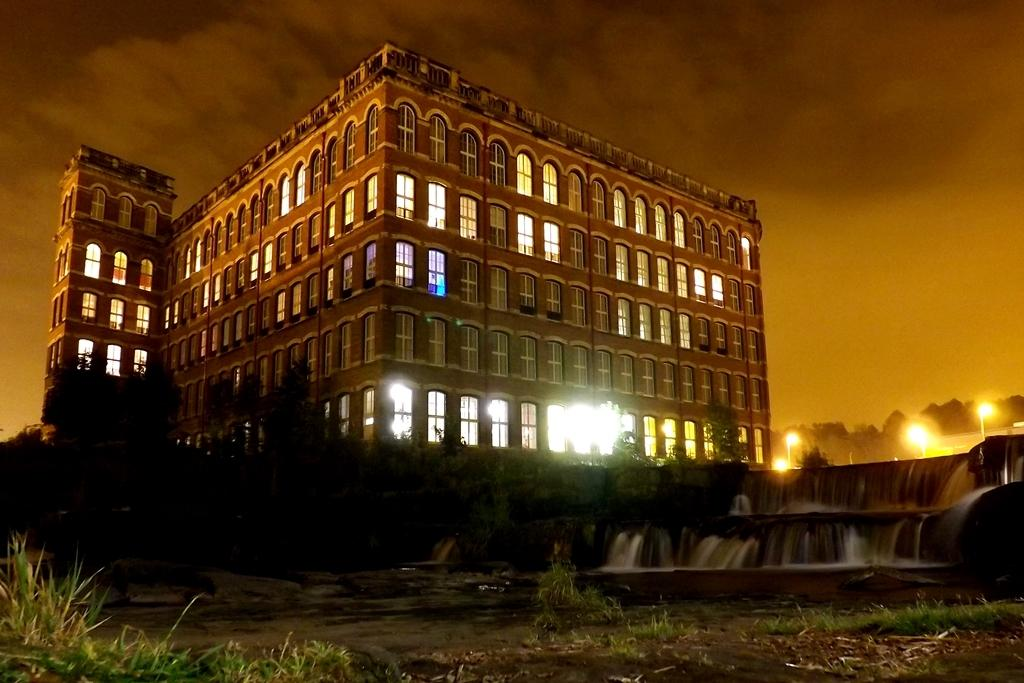What type of structure is present in the image? There is a building in the image. What feature of the building is mentioned in the facts? The building has windows. What can be observed about the windows in the image? The windows have lights. What type of natural elements are present in the image? There are trees and plants in the image. What else can be seen in the image besides the building and natural elements? There is water visible in the image. What type of credit can be seen on the frame of the building in the image? There is no credit or frame mentioned in the image; it only describes the building, windows, lights, trees, plants, and water. 